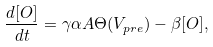<formula> <loc_0><loc_0><loc_500><loc_500>\frac { d [ O ] } { d t } = \gamma \alpha A \Theta ( V _ { p r e } ) - \beta [ O ] ,</formula> 